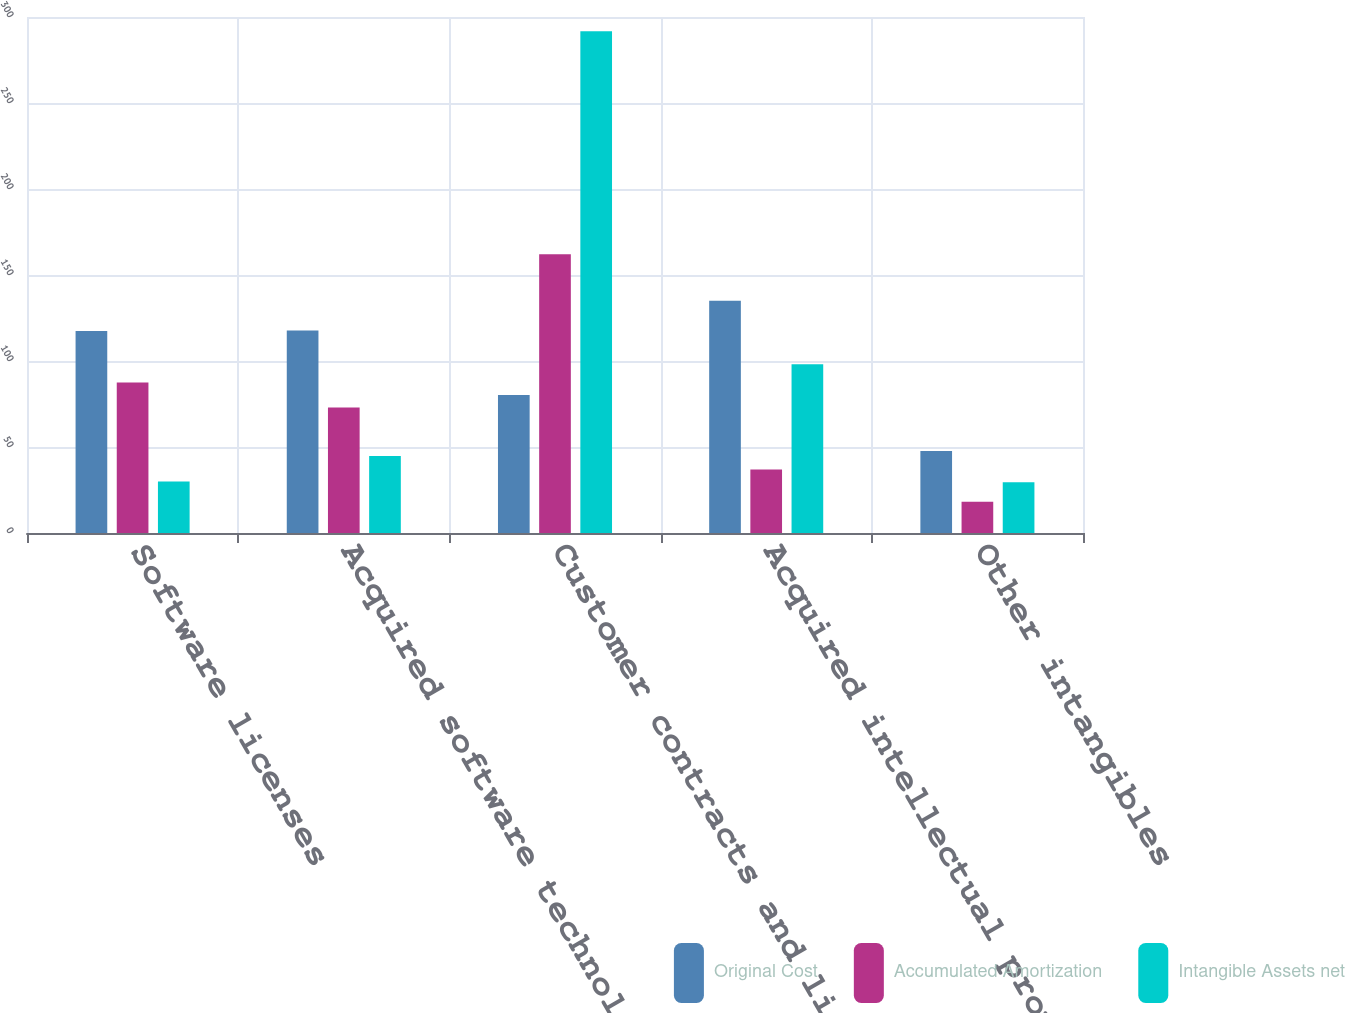<chart> <loc_0><loc_0><loc_500><loc_500><stacked_bar_chart><ecel><fcel>Software licenses<fcel>Acquired software technology<fcel>Customer contracts and lists<fcel>Acquired intellectual property<fcel>Other intangibles<nl><fcel>Original Cost<fcel>117.5<fcel>117.8<fcel>80.25<fcel>135<fcel>47.7<nl><fcel>Accumulated Amortization<fcel>87.5<fcel>73<fcel>162.1<fcel>36.9<fcel>18.2<nl><fcel>Intangible Assets net<fcel>30<fcel>44.8<fcel>291.7<fcel>98.1<fcel>29.5<nl></chart> 